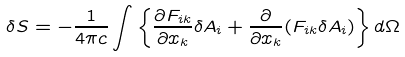<formula> <loc_0><loc_0><loc_500><loc_500>\delta S = - \frac { 1 } { 4 \pi c } \int \left \{ \frac { \partial F _ { i k } } { \partial x _ { k } } \delta A _ { i } + \frac { \partial } { \partial x _ { k } } ( F _ { i k } \delta A _ { i } ) \right \} d \Omega</formula> 